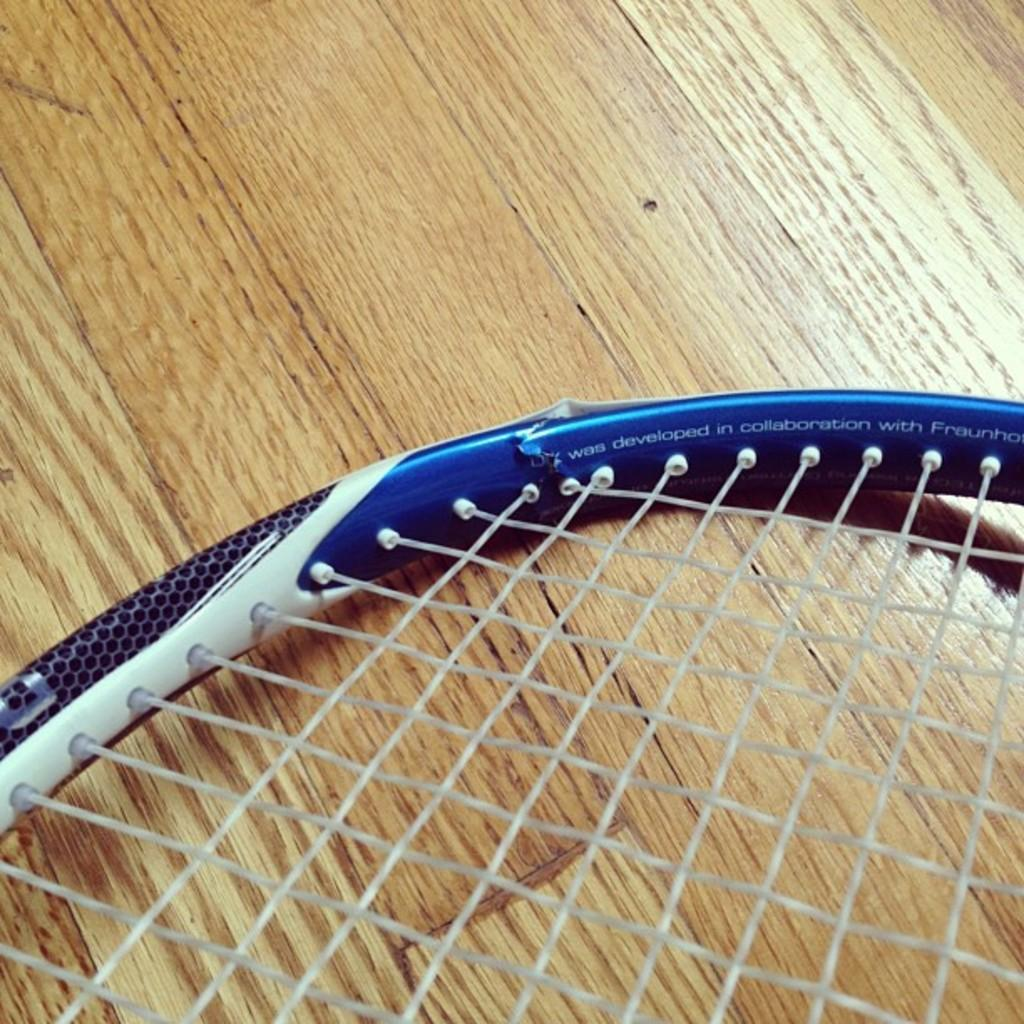What type of sports equipment is visible in the image? There is a badminton racket in the image. What is the color of the badminton racket? The badminton racket is blue in color. On what surface is the badminton racket placed? The badminton racket is placed on a brown surface. What other object related to badminton can be seen in the image? There is a white color net in the image. Can you see the moon in the image? No, the moon is not present in the image. What type of shoe is placed next to the badminton racket? There is no shoe present in the image; only the badminton racket and net are visible. 